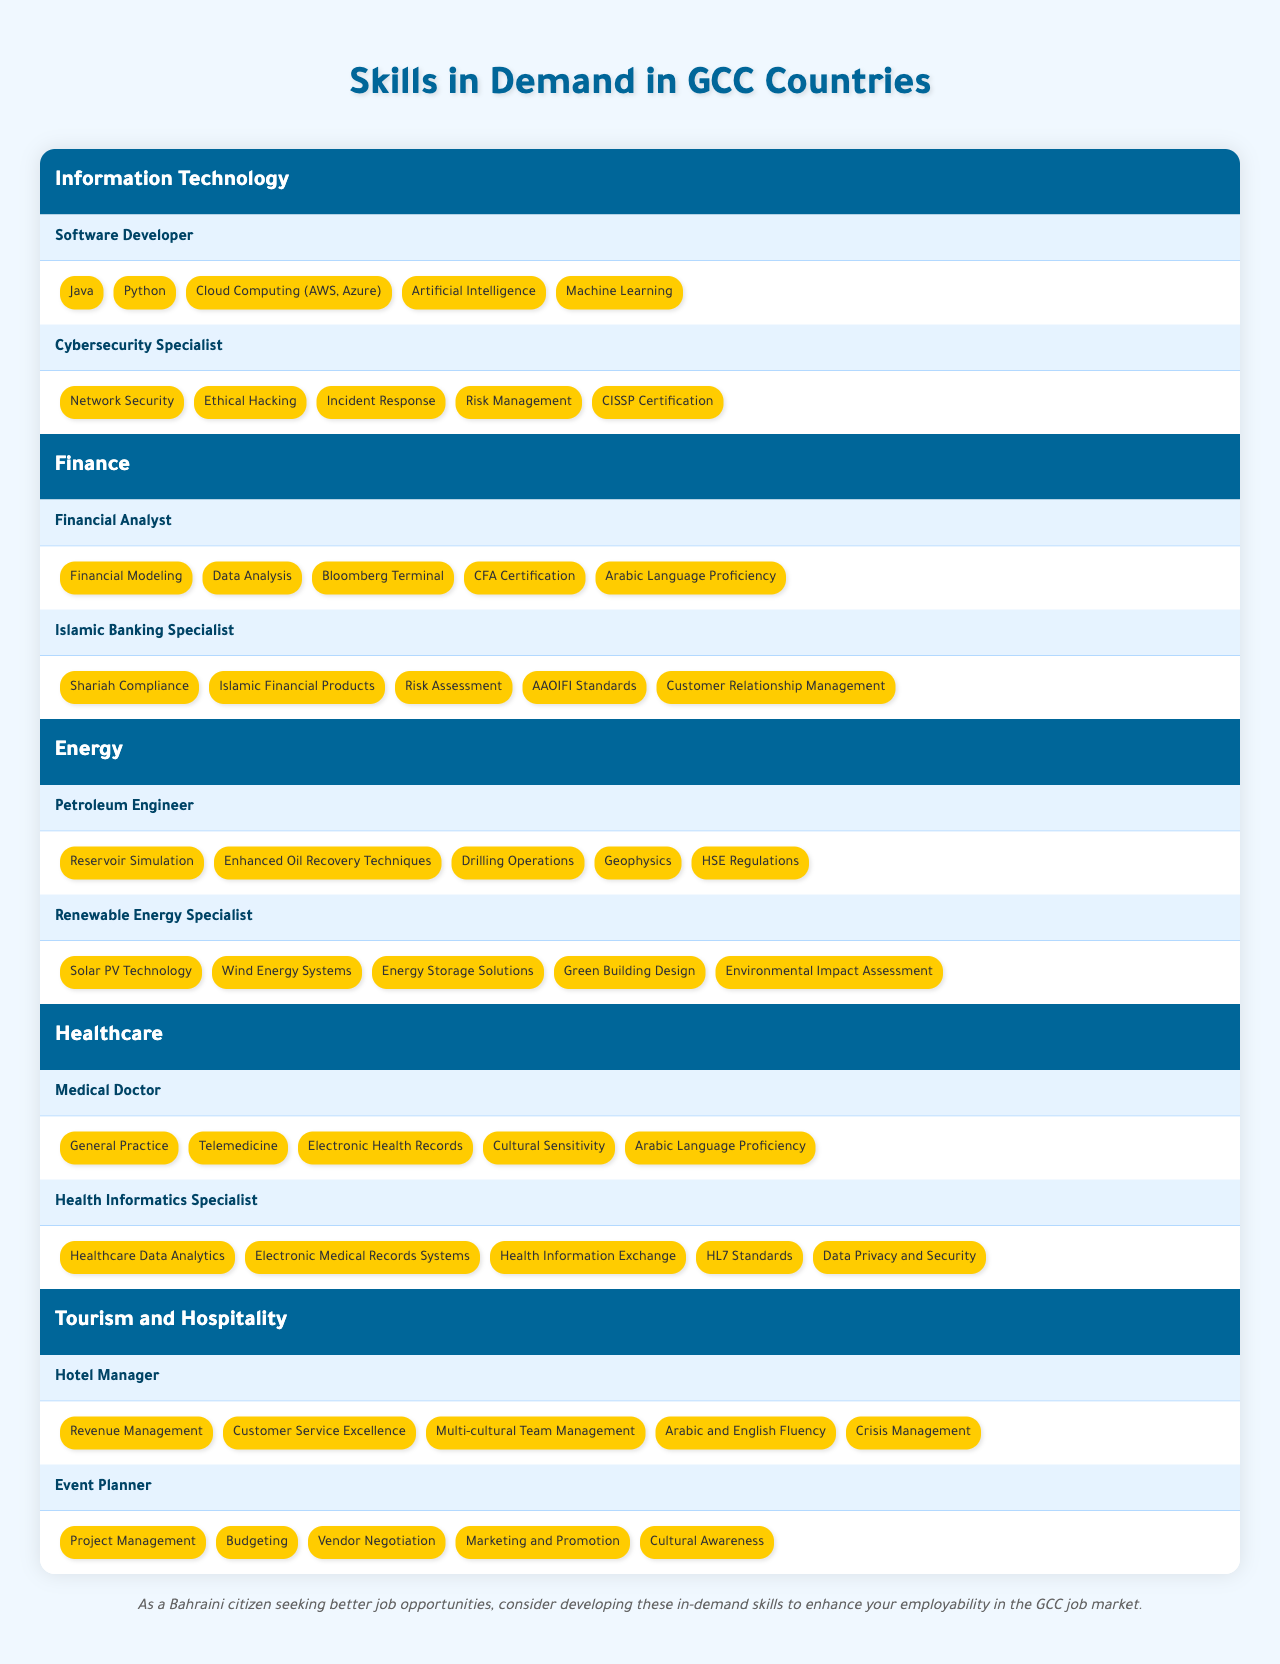What are the top three skills required for a Software Developer in the GCC? The skills listed for a Software Developer are "Java," "Python," and "Cloud Computing (AWS, Azure)." These are the first three skills mentioned under that job role.
Answer: Java, Python, Cloud Computing (AWS, Azure) Which job role in the Healthcare sector requires Arabic Language Proficiency? The role of "Medical Doctor" lists "Arabic Language Proficiency" among its required skills, indicating that this position values fluency in Arabic.
Answer: Medical Doctor How many skills are listed for the Renewable Energy Specialist role? The role of Renewable Energy Specialist has five listed skills: "Solar PV Technology," "Wind Energy Systems," "Energy Storage Solutions," "Green Building Design," and "Environmental Impact Assessment." By counting them, we confirm there are five skills.
Answer: 5 Is "CFA Certification" a skill required for Financial Analysts? "CFA Certification" is listed among the skills required for the Financial Analyst role, confirming that it is indeed a necessary qualification for this job position.
Answer: Yes What sectors have job roles that require customer relationship management skills? Looking at the job roles under "Finance," the "Islamic Banking Specialist" requires "Customer Relationship Management." Additionally, under "Tourism and Hospitality," the "Hotel Manager" role also mentions "Customer Service Excellence," which is related to customer relationship management. Therefore, the Finance and Tourism sectors mention customer-related skills.
Answer: Finance, Tourism and Hospitality Which sector has job roles related to Renewable Energy? The Energy sector includes the "Renewable Energy Specialist" role, specifically focusing on renewable energy skills, as well as the Petroleum Engineer role, which might involve renewable discussions in modern industry. Therefore, the Energy sector covers this area.
Answer: Energy If I want to pursue a career in Cybersecurity in the GCC, which two skills should I prioritize? The skills for a Cybersecurity Specialist include "Network Security" and "Ethical Hacking." These are the first two skills that would be beneficial to focus on for a career in this field.
Answer: Network Security, Ethical Hacking What is the common skill shared by both Medical Doctor and Financial Analyst roles? Both job roles require "Arabic Language Proficiency," which indicates that this skill is valuable across both sectors, specifically within the GCC context where Arabic is significant.
Answer: Arabic Language Proficiency How many skills in total are required for the Hotel Manager? The Hotel Manager role lists five skills: "Revenue Management," "Customer Service Excellence," "Multi-cultural Team Management," "Arabic and English Fluency," and "Crisis Management." This totals to five distinct skills for this role.
Answer: 5 Which job role in the Finance sector has the most specific skill set related to Islamic finance? The "Islamic Banking Specialist" role has skills specifically tailored to Islamic finance, requiring knowledge of "Shariah Compliance," "Islamic Financial Products," and other relevant areas that make it distinct in this sector.
Answer: Islamic Banking Specialist 